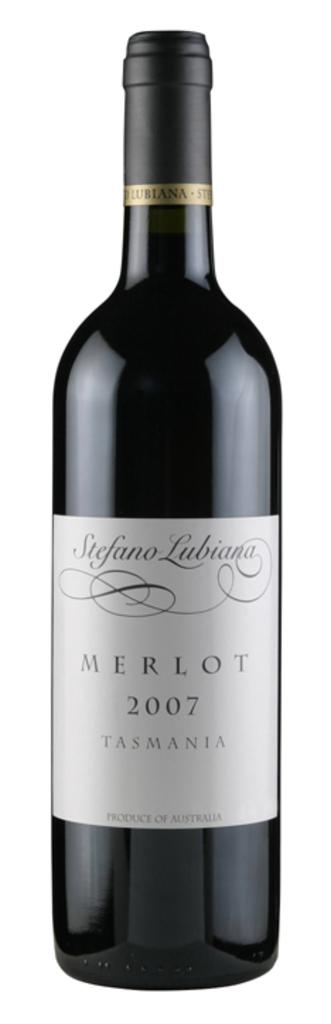<image>
Share a concise interpretation of the image provided. A bottle of Stefano Lubiana Merlot is from 2007. 